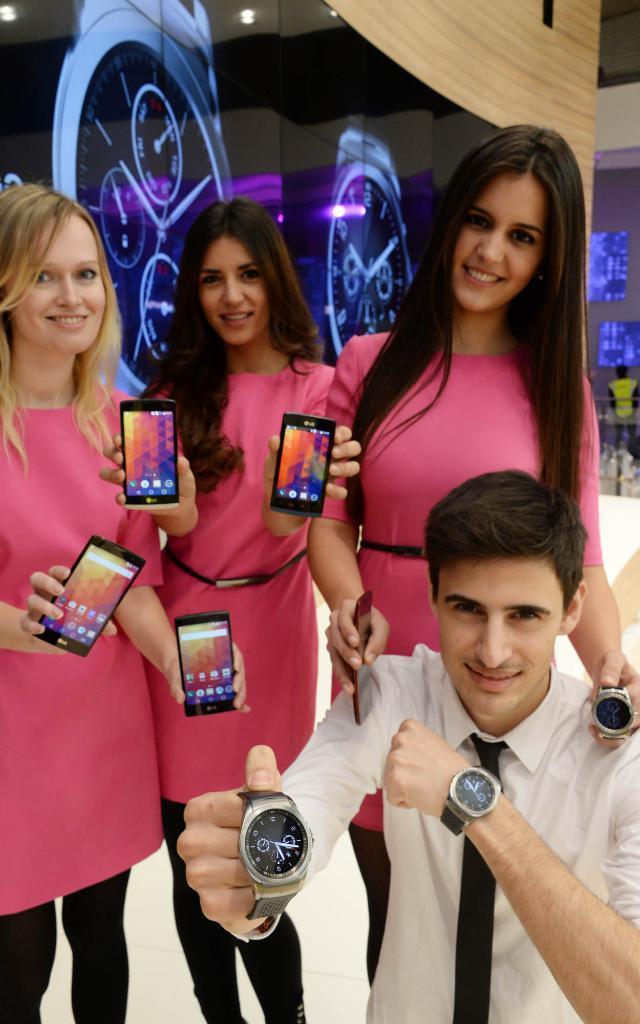Describe this image in one or two sentences. In this image in the foreground there are some people three of them are standing, and one person is sitting and he is holding a watch, and there are three members who are holding mobile phones. In the background there is a screen, and some televisions and one person. 